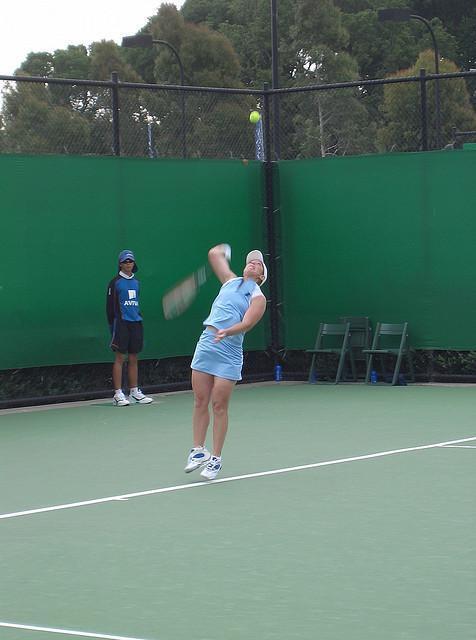How many chairs are available?
Give a very brief answer. 2. How many people can you see?
Give a very brief answer. 2. 